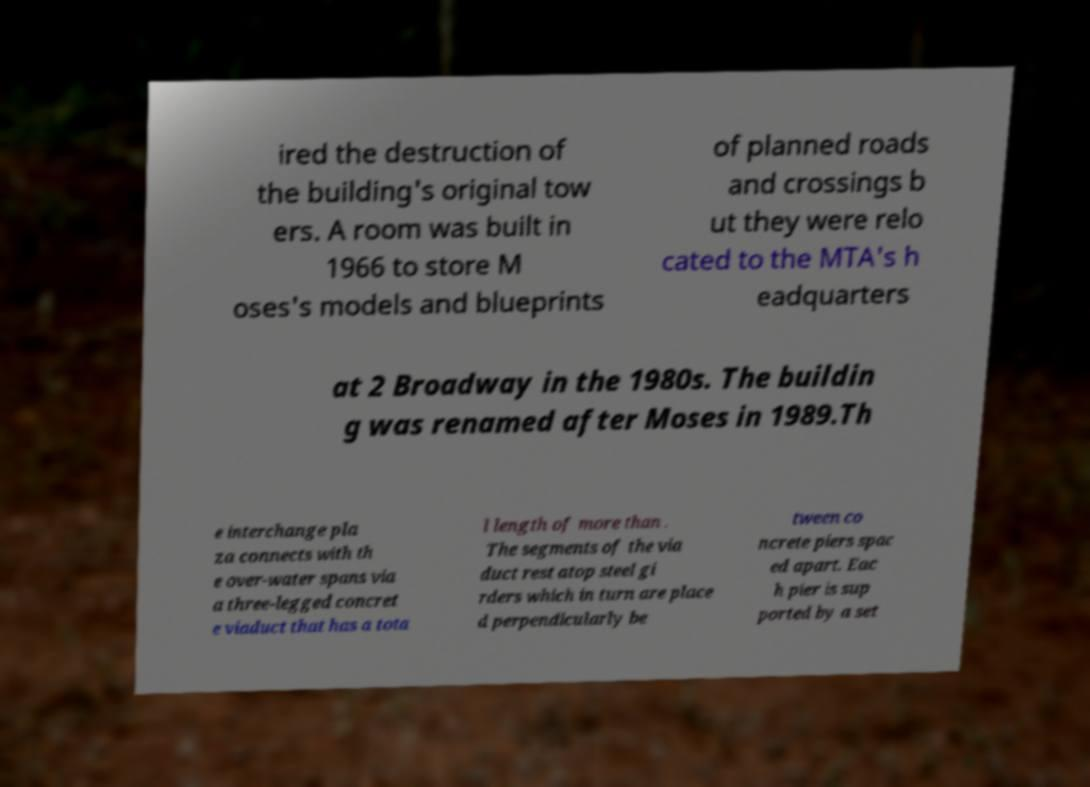What messages or text are displayed in this image? I need them in a readable, typed format. ired the destruction of the building's original tow ers. A room was built in 1966 to store M oses's models and blueprints of planned roads and crossings b ut they were relo cated to the MTA's h eadquarters at 2 Broadway in the 1980s. The buildin g was renamed after Moses in 1989.Th e interchange pla za connects with th e over-water spans via a three-legged concret e viaduct that has a tota l length of more than . The segments of the via duct rest atop steel gi rders which in turn are place d perpendicularly be tween co ncrete piers spac ed apart. Eac h pier is sup ported by a set 